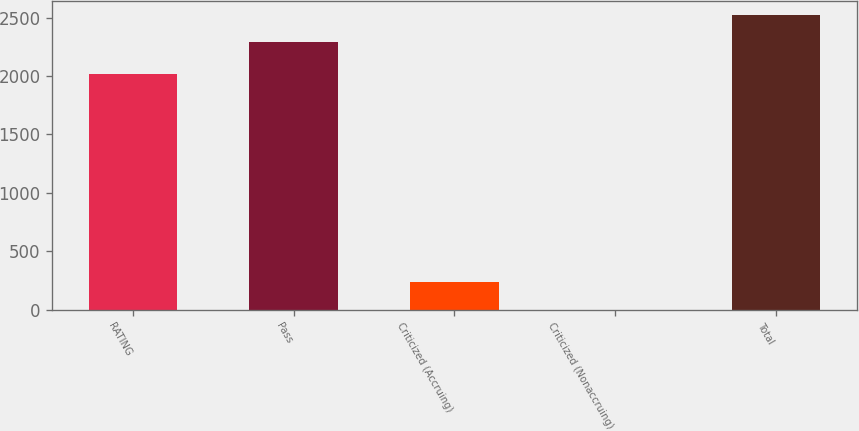Convert chart to OTSL. <chart><loc_0><loc_0><loc_500><loc_500><bar_chart><fcel>RATING<fcel>Pass<fcel>Criticized (Accruing)<fcel>Criticized (Nonaccruing)<fcel>Total<nl><fcel>2016<fcel>2287<fcel>233.7<fcel>2<fcel>2518.7<nl></chart> 